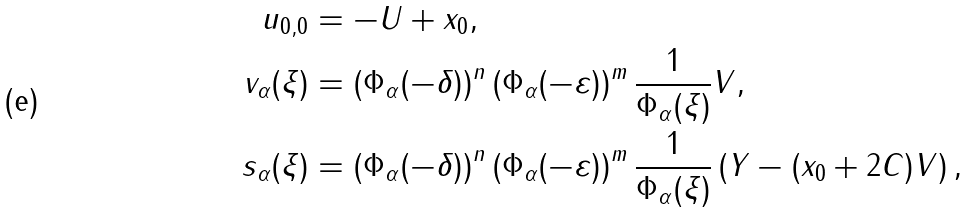Convert formula to latex. <formula><loc_0><loc_0><loc_500><loc_500>u _ { 0 , 0 } & = - U + x _ { 0 } , \\ v _ { \alpha } ( \xi ) & = \left ( \Phi _ { \alpha } ( - \delta ) \right ) ^ { n } \left ( \Phi _ { \alpha } ( - \varepsilon ) \right ) ^ { m } \frac { 1 } { \Phi _ { \alpha } ( \xi ) } V , \\ s _ { \alpha } ( \xi ) & = \left ( \Phi _ { \alpha } ( - \delta ) \right ) ^ { n } \left ( \Phi _ { \alpha } ( - \varepsilon ) \right ) ^ { m } \frac { 1 } { \Phi _ { \alpha } ( \xi ) } \left ( Y - ( x _ { 0 } + 2 C ) V \right ) ,</formula> 